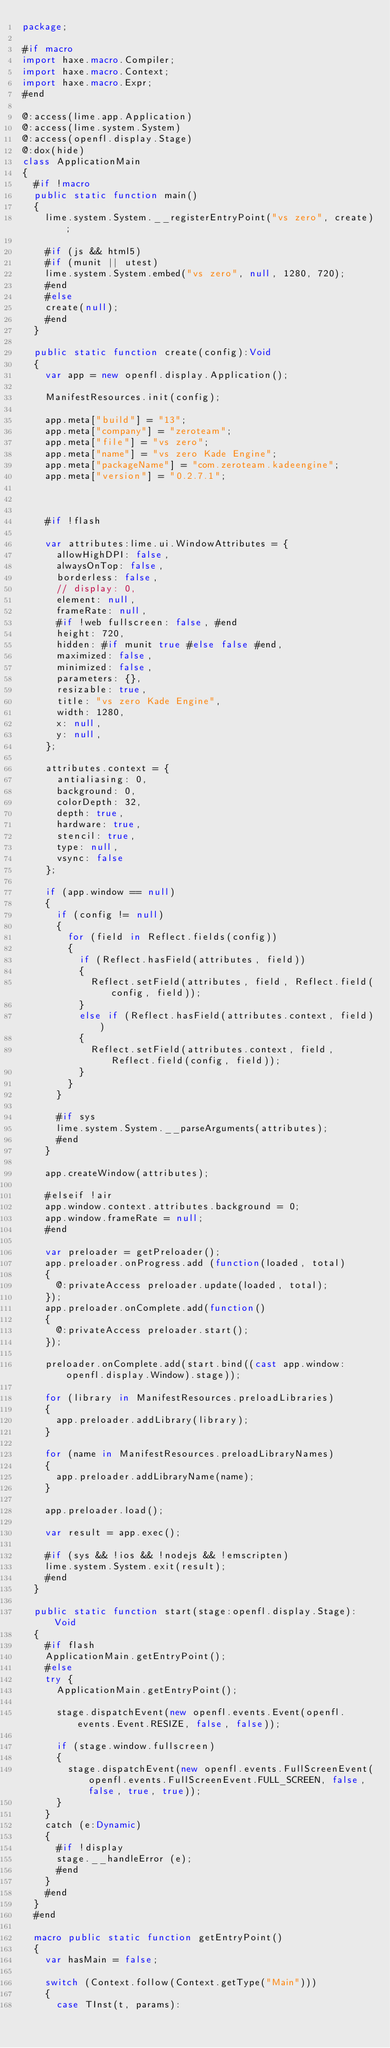Convert code to text. <code><loc_0><loc_0><loc_500><loc_500><_Haxe_>package;

#if macro
import haxe.macro.Compiler;
import haxe.macro.Context;
import haxe.macro.Expr;
#end

@:access(lime.app.Application)
@:access(lime.system.System)
@:access(openfl.display.Stage)
@:dox(hide)
class ApplicationMain
{
	#if !macro
	public static function main()
	{
		lime.system.System.__registerEntryPoint("vs zero", create);

		#if (js && html5)
		#if (munit || utest)
		lime.system.System.embed("vs zero", null, 1280, 720);
		#end
		#else
		create(null);
		#end
	}

	public static function create(config):Void
	{
		var app = new openfl.display.Application();

		ManifestResources.init(config);

		app.meta["build"] = "13";
		app.meta["company"] = "zeroteam";
		app.meta["file"] = "vs zero";
		app.meta["name"] = "vs zero Kade Engine";
		app.meta["packageName"] = "com.zeroteam.kadeengine";
		app.meta["version"] = "0.2.7.1";

		

		#if !flash
		
		var attributes:lime.ui.WindowAttributes = {
			allowHighDPI: false,
			alwaysOnTop: false,
			borderless: false,
			// display: 0,
			element: null,
			frameRate: null,
			#if !web fullscreen: false, #end
			height: 720,
			hidden: #if munit true #else false #end,
			maximized: false,
			minimized: false,
			parameters: {},
			resizable: true,
			title: "vs zero Kade Engine",
			width: 1280,
			x: null,
			y: null,
		};

		attributes.context = {
			antialiasing: 0,
			background: 0,
			colorDepth: 32,
			depth: true,
			hardware: true,
			stencil: true,
			type: null,
			vsync: false
		};

		if (app.window == null)
		{
			if (config != null)
			{
				for (field in Reflect.fields(config))
				{
					if (Reflect.hasField(attributes, field))
					{
						Reflect.setField(attributes, field, Reflect.field(config, field));
					}
					else if (Reflect.hasField(attributes.context, field))
					{
						Reflect.setField(attributes.context, field, Reflect.field(config, field));
					}
				}
			}

			#if sys
			lime.system.System.__parseArguments(attributes);
			#end
		}

		app.createWindow(attributes);
		
		#elseif !air
		app.window.context.attributes.background = 0;
		app.window.frameRate = null;
		#end

		var preloader = getPreloader();
		app.preloader.onProgress.add (function(loaded, total)
		{
			@:privateAccess preloader.update(loaded, total);
		});
		app.preloader.onComplete.add(function()
		{
			@:privateAccess preloader.start();
		});

		preloader.onComplete.add(start.bind((cast app.window:openfl.display.Window).stage));

		for (library in ManifestResources.preloadLibraries)
		{
			app.preloader.addLibrary(library);
		}

		for (name in ManifestResources.preloadLibraryNames)
		{
			app.preloader.addLibraryName(name);
		}

		app.preloader.load();

		var result = app.exec();

		#if (sys && !ios && !nodejs && !emscripten)
		lime.system.System.exit(result);
		#end
	}

	public static function start(stage:openfl.display.Stage):Void
	{
		#if flash
		ApplicationMain.getEntryPoint();
		#else
		try {
			ApplicationMain.getEntryPoint();

			stage.dispatchEvent(new openfl.events.Event(openfl.events.Event.RESIZE, false, false));

			if (stage.window.fullscreen)
			{
				stage.dispatchEvent(new openfl.events.FullScreenEvent(openfl.events.FullScreenEvent.FULL_SCREEN, false, false, true, true));
			}
		}
		catch (e:Dynamic)
		{
			#if !display
			stage.__handleError (e);
			#end
		}
		#end
	}
	#end

	macro public static function getEntryPoint()
	{
		var hasMain = false;

		switch (Context.follow(Context.getType("Main")))
		{
			case TInst(t, params):
</code> 